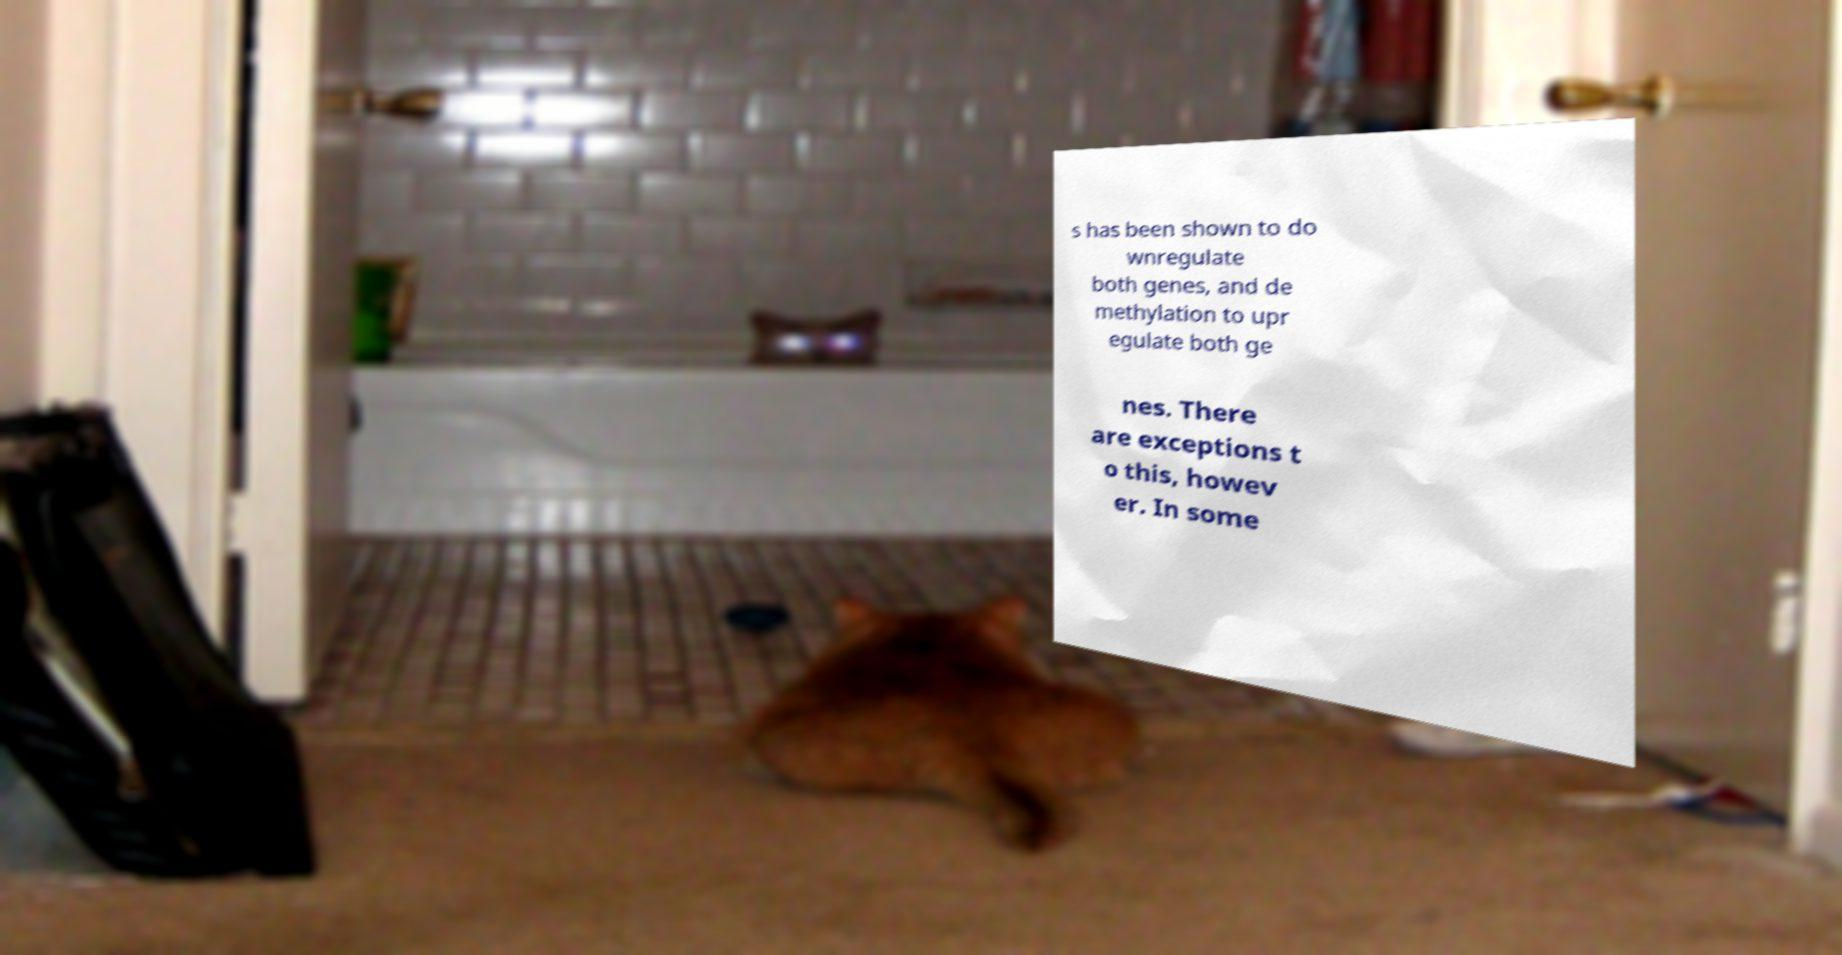Can you accurately transcribe the text from the provided image for me? s has been shown to do wnregulate both genes, and de methylation to upr egulate both ge nes. There are exceptions t o this, howev er. In some 